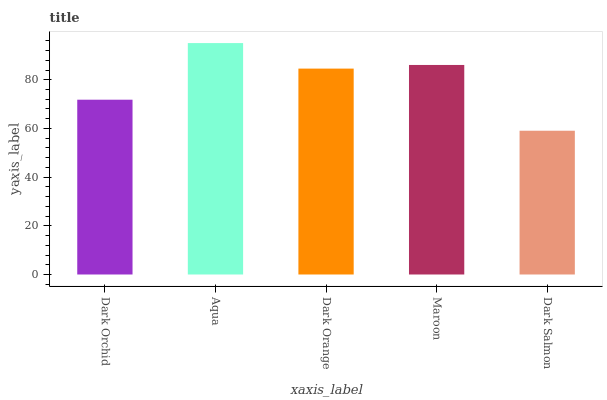Is Dark Salmon the minimum?
Answer yes or no. Yes. Is Aqua the maximum?
Answer yes or no. Yes. Is Dark Orange the minimum?
Answer yes or no. No. Is Dark Orange the maximum?
Answer yes or no. No. Is Aqua greater than Dark Orange?
Answer yes or no. Yes. Is Dark Orange less than Aqua?
Answer yes or no. Yes. Is Dark Orange greater than Aqua?
Answer yes or no. No. Is Aqua less than Dark Orange?
Answer yes or no. No. Is Dark Orange the high median?
Answer yes or no. Yes. Is Dark Orange the low median?
Answer yes or no. Yes. Is Aqua the high median?
Answer yes or no. No. Is Aqua the low median?
Answer yes or no. No. 